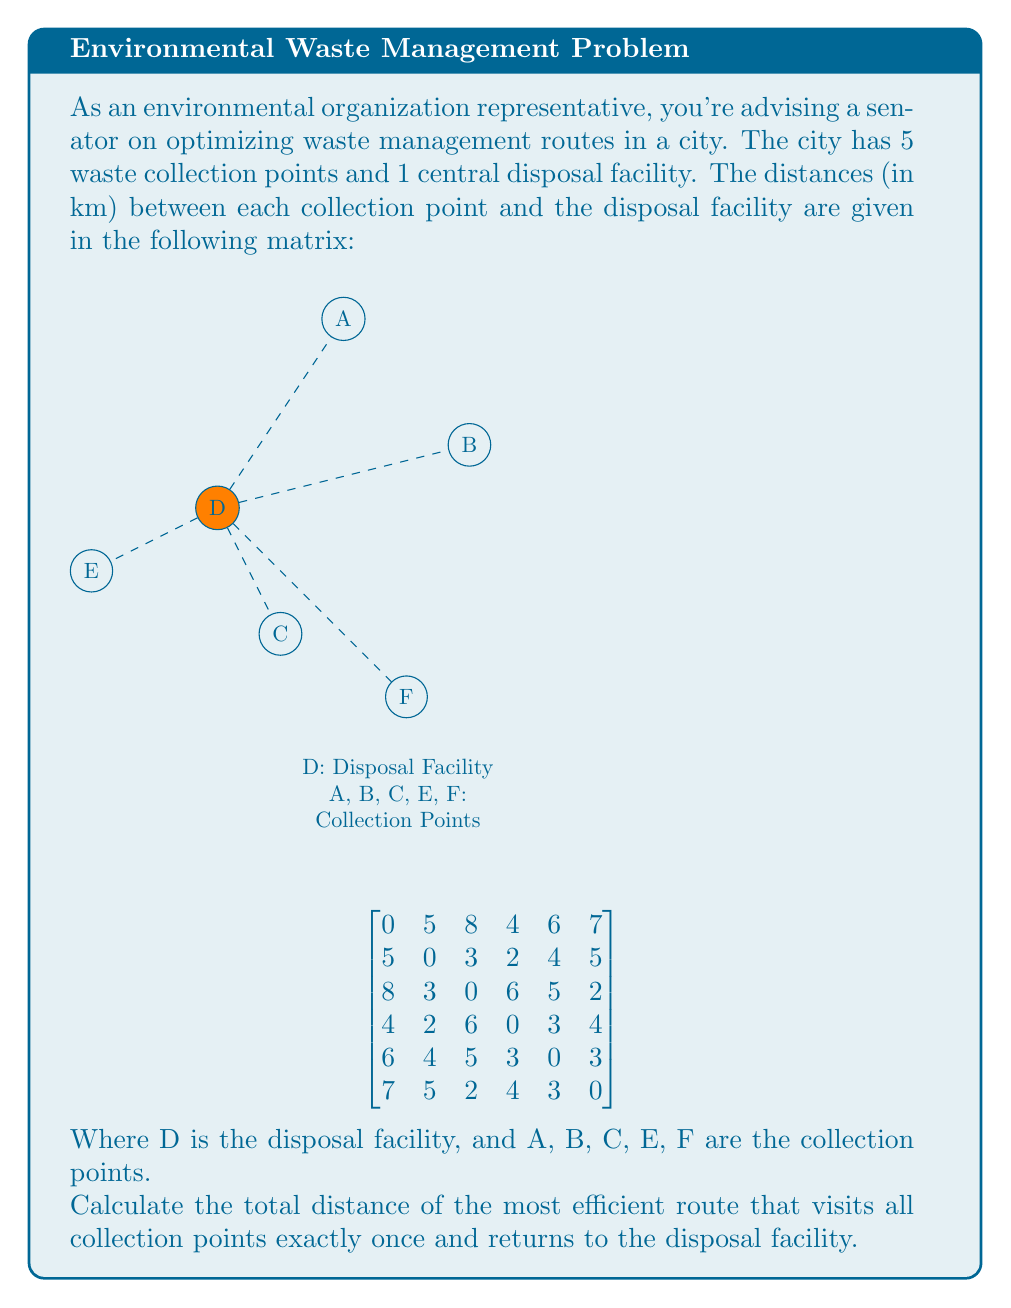Can you answer this question? This problem is an instance of the Traveling Salesman Problem (TSP), which aims to find the shortest possible route that visits each city exactly once and returns to the origin.

To solve this, we'll use the nearest neighbor heuristic, which is a simple but effective approximation for the TSP:

1) Start at the disposal facility (D).
2) Visit the nearest unvisited collection point.
3) Repeat step 2 until all points are visited.
4) Return to the disposal facility.

Let's follow the algorithm:

1) Start at D
2) Nearest to D is C (4 km)
   Route: D → C, Distance: 4 km
3) Nearest to C (excluding D) is E (3 km)
   Route: D → C → E, Distance: 4 + 3 = 7 km
4) Nearest to E (excluding D and C) is F (3 km)
   Route: D → C → E → F, Distance: 7 + 3 = 10 km
5) Nearest to F (excluding D, C, and E) is B (2 km)
   Route: D → C → E → F → B, Distance: 10 + 2 = 12 km
6) Only A remains, distance from B to A is 3 km
   Route: D → C → E → F → B → A, Distance: 12 + 3 = 15 km
7) Return to D from A, distance is 5 km
   Final route: D → C → E → F → B → A → D
   Total distance: 15 + 5 = 20 km

Therefore, the most efficient route visiting all collection points once and returning to the disposal facility is 20 km long.
Answer: 20 km 